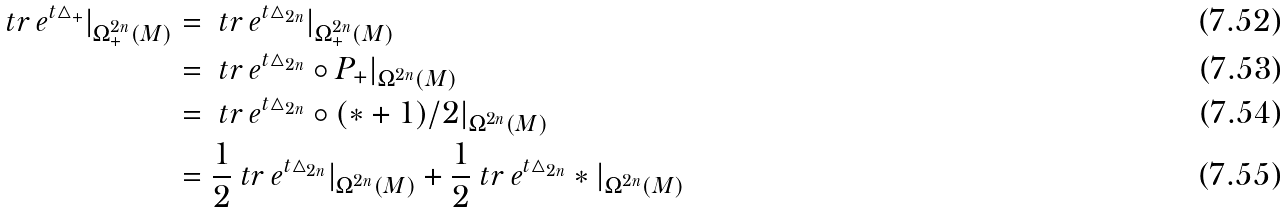<formula> <loc_0><loc_0><loc_500><loc_500>\ t r \, e ^ { t \bigtriangleup _ { + } } | _ { \Omega _ { + } ^ { 2 n } ( M ) } & = \ t r \, e ^ { t \bigtriangleup _ { 2 n } } | _ { \Omega _ { + } ^ { 2 n } ( M ) } \\ \ & = \ t r \, e ^ { t \bigtriangleup _ { 2 n } } \circ P _ { + } | _ { \Omega ^ { 2 n } ( M ) } \\ & = \ t r \, e ^ { t \bigtriangleup _ { 2 n } } \circ ( * + 1 ) / 2 | _ { \Omega ^ { 2 n } ( M ) } \\ & = \frac { 1 } { 2 } \ t r \, e ^ { t \bigtriangleup _ { 2 n } } | _ { \Omega ^ { 2 n } ( M ) } + \frac { 1 } { 2 } \ t r \, e ^ { t \bigtriangleup _ { 2 n } } * | _ { \Omega ^ { 2 n } ( M ) } \</formula> 